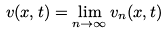Convert formula to latex. <formula><loc_0><loc_0><loc_500><loc_500>v ( x , t ) = \lim _ { n \to \infty } v _ { n } ( x , t )</formula> 